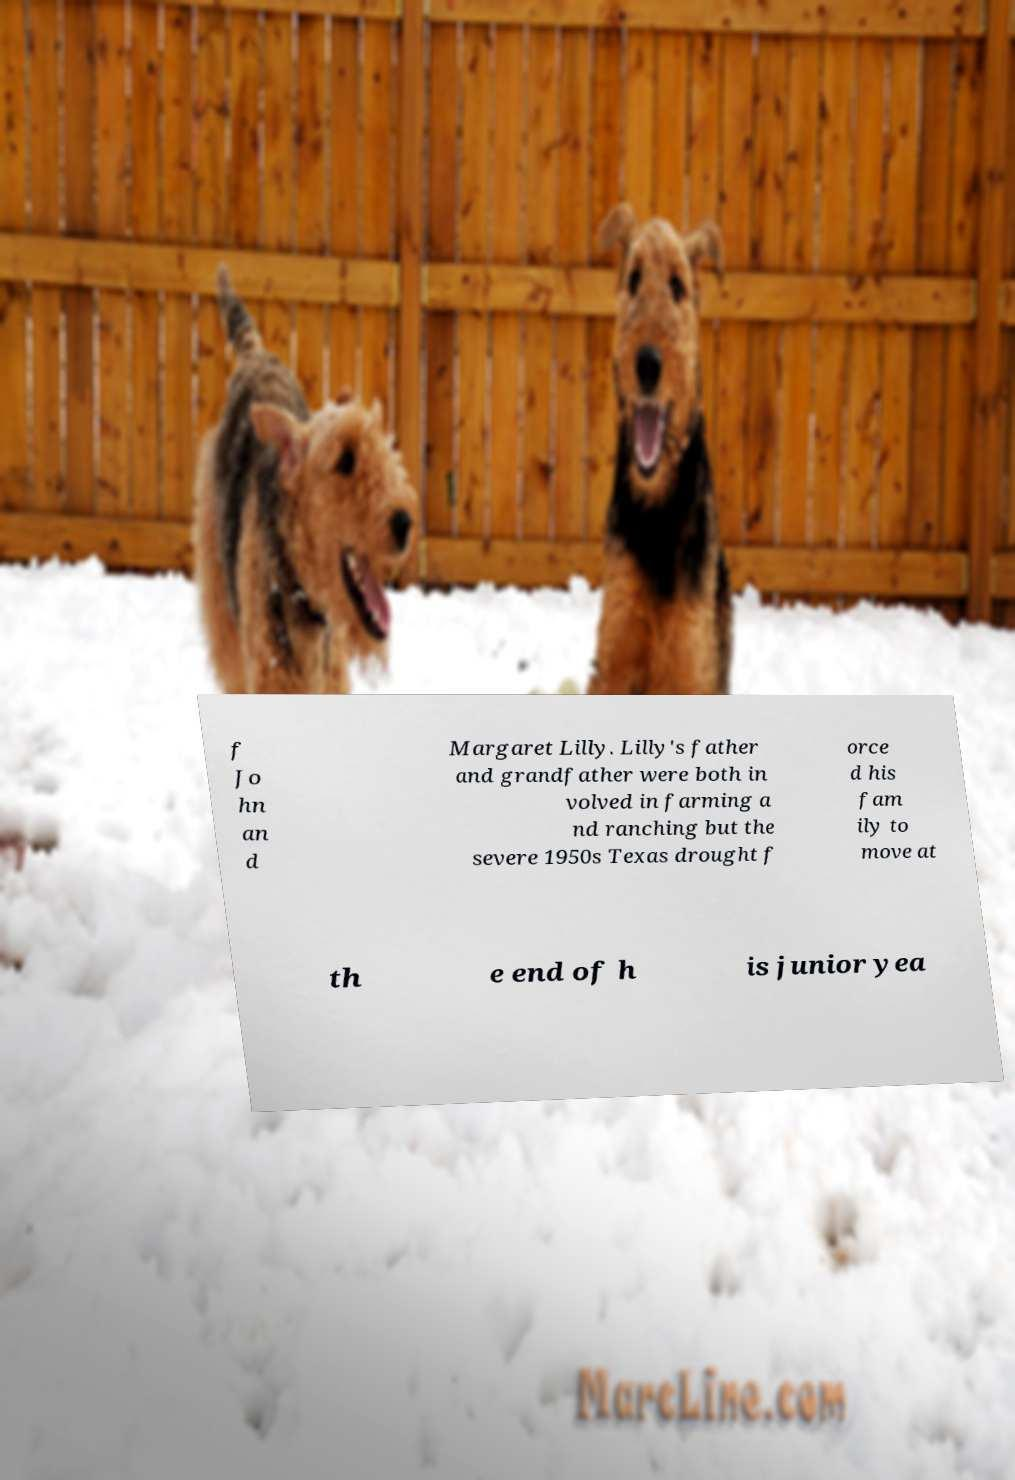I need the written content from this picture converted into text. Can you do that? f Jo hn an d Margaret Lilly. Lilly's father and grandfather were both in volved in farming a nd ranching but the severe 1950s Texas drought f orce d his fam ily to move at th e end of h is junior yea 